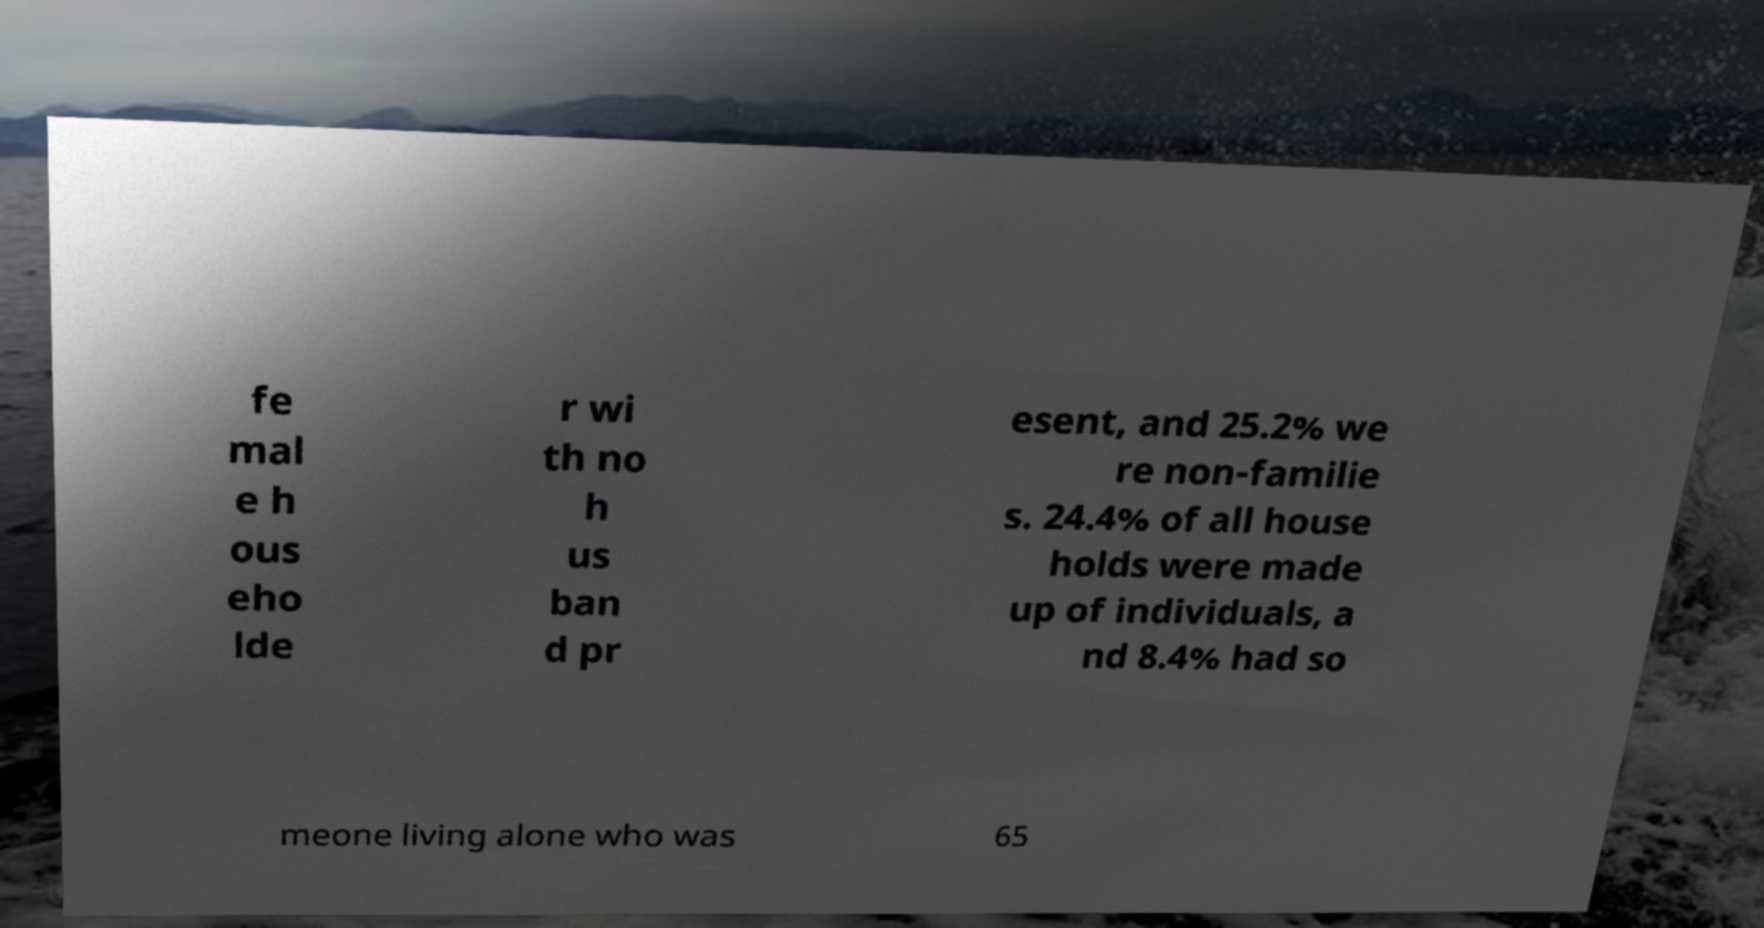What messages or text are displayed in this image? I need them in a readable, typed format. fe mal e h ous eho lde r wi th no h us ban d pr esent, and 25.2% we re non-familie s. 24.4% of all house holds were made up of individuals, a nd 8.4% had so meone living alone who was 65 